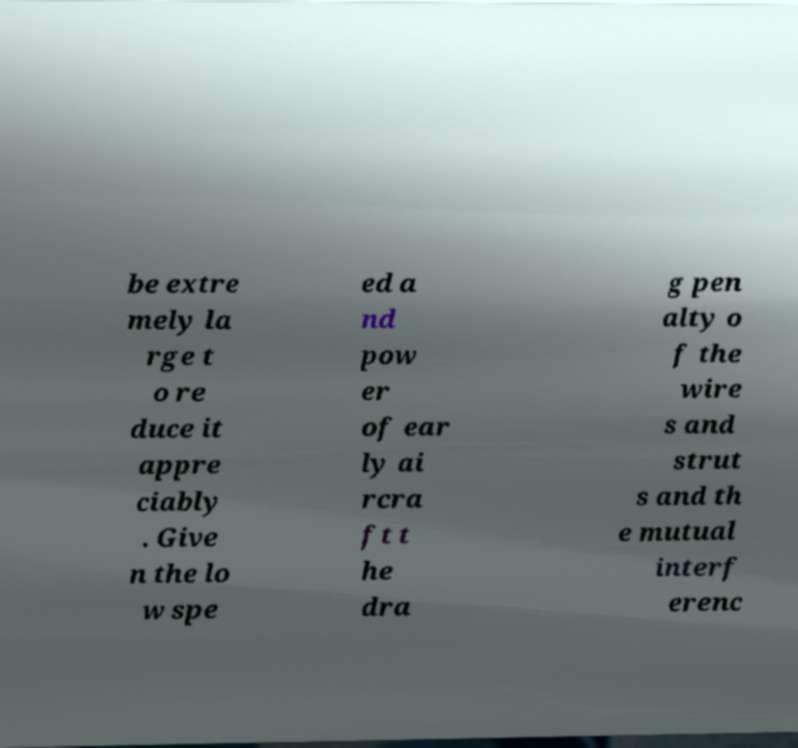Please read and relay the text visible in this image. What does it say? be extre mely la rge t o re duce it appre ciably . Give n the lo w spe ed a nd pow er of ear ly ai rcra ft t he dra g pen alty o f the wire s and strut s and th e mutual interf erenc 